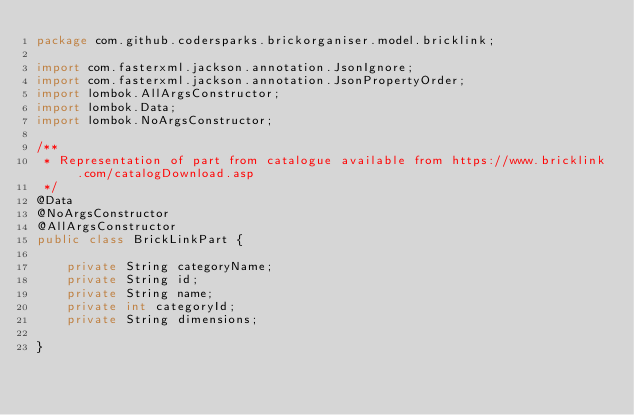<code> <loc_0><loc_0><loc_500><loc_500><_Java_>package com.github.codersparks.brickorganiser.model.bricklink;

import com.fasterxml.jackson.annotation.JsonIgnore;
import com.fasterxml.jackson.annotation.JsonPropertyOrder;
import lombok.AllArgsConstructor;
import lombok.Data;
import lombok.NoArgsConstructor;

/**
 * Representation of part from catalogue available from https://www.bricklink.com/catalogDownload.asp
 */
@Data
@NoArgsConstructor
@AllArgsConstructor
public class BrickLinkPart {

    private String categoryName;
    private String id;
    private String name;
    private int categoryId;
    private String dimensions;

}
</code> 